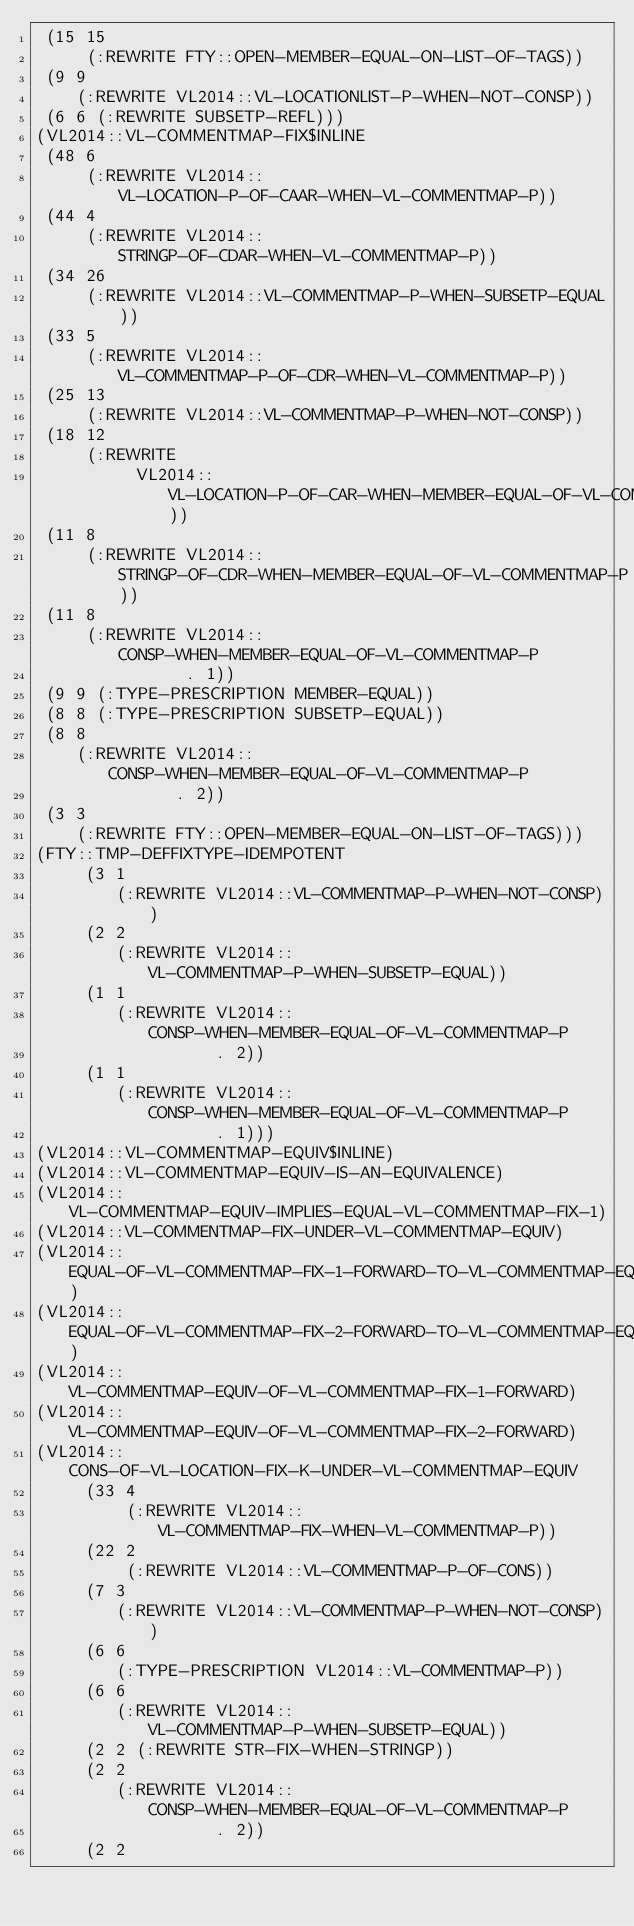<code> <loc_0><loc_0><loc_500><loc_500><_Lisp_> (15 15
     (:REWRITE FTY::OPEN-MEMBER-EQUAL-ON-LIST-OF-TAGS))
 (9 9
    (:REWRITE VL2014::VL-LOCATIONLIST-P-WHEN-NOT-CONSP))
 (6 6 (:REWRITE SUBSETP-REFL)))
(VL2014::VL-COMMENTMAP-FIX$INLINE
 (48 6
     (:REWRITE VL2014::VL-LOCATION-P-OF-CAAR-WHEN-VL-COMMENTMAP-P))
 (44 4
     (:REWRITE VL2014::STRINGP-OF-CDAR-WHEN-VL-COMMENTMAP-P))
 (34 26
     (:REWRITE VL2014::VL-COMMENTMAP-P-WHEN-SUBSETP-EQUAL))
 (33 5
     (:REWRITE VL2014::VL-COMMENTMAP-P-OF-CDR-WHEN-VL-COMMENTMAP-P))
 (25 13
     (:REWRITE VL2014::VL-COMMENTMAP-P-WHEN-NOT-CONSP))
 (18 12
     (:REWRITE
          VL2014::VL-LOCATION-P-OF-CAR-WHEN-MEMBER-EQUAL-OF-VL-COMMENTMAP-P))
 (11 8
     (:REWRITE VL2014::STRINGP-OF-CDR-WHEN-MEMBER-EQUAL-OF-VL-COMMENTMAP-P))
 (11 8
     (:REWRITE VL2014::CONSP-WHEN-MEMBER-EQUAL-OF-VL-COMMENTMAP-P
               . 1))
 (9 9 (:TYPE-PRESCRIPTION MEMBER-EQUAL))
 (8 8 (:TYPE-PRESCRIPTION SUBSETP-EQUAL))
 (8 8
    (:REWRITE VL2014::CONSP-WHEN-MEMBER-EQUAL-OF-VL-COMMENTMAP-P
              . 2))
 (3 3
    (:REWRITE FTY::OPEN-MEMBER-EQUAL-ON-LIST-OF-TAGS)))
(FTY::TMP-DEFFIXTYPE-IDEMPOTENT
     (3 1
        (:REWRITE VL2014::VL-COMMENTMAP-P-WHEN-NOT-CONSP))
     (2 2
        (:REWRITE VL2014::VL-COMMENTMAP-P-WHEN-SUBSETP-EQUAL))
     (1 1
        (:REWRITE VL2014::CONSP-WHEN-MEMBER-EQUAL-OF-VL-COMMENTMAP-P
                  . 2))
     (1 1
        (:REWRITE VL2014::CONSP-WHEN-MEMBER-EQUAL-OF-VL-COMMENTMAP-P
                  . 1)))
(VL2014::VL-COMMENTMAP-EQUIV$INLINE)
(VL2014::VL-COMMENTMAP-EQUIV-IS-AN-EQUIVALENCE)
(VL2014::VL-COMMENTMAP-EQUIV-IMPLIES-EQUAL-VL-COMMENTMAP-FIX-1)
(VL2014::VL-COMMENTMAP-FIX-UNDER-VL-COMMENTMAP-EQUIV)
(VL2014::EQUAL-OF-VL-COMMENTMAP-FIX-1-FORWARD-TO-VL-COMMENTMAP-EQUIV)
(VL2014::EQUAL-OF-VL-COMMENTMAP-FIX-2-FORWARD-TO-VL-COMMENTMAP-EQUIV)
(VL2014::VL-COMMENTMAP-EQUIV-OF-VL-COMMENTMAP-FIX-1-FORWARD)
(VL2014::VL-COMMENTMAP-EQUIV-OF-VL-COMMENTMAP-FIX-2-FORWARD)
(VL2014::CONS-OF-VL-LOCATION-FIX-K-UNDER-VL-COMMENTMAP-EQUIV
     (33 4
         (:REWRITE VL2014::VL-COMMENTMAP-FIX-WHEN-VL-COMMENTMAP-P))
     (22 2
         (:REWRITE VL2014::VL-COMMENTMAP-P-OF-CONS))
     (7 3
        (:REWRITE VL2014::VL-COMMENTMAP-P-WHEN-NOT-CONSP))
     (6 6
        (:TYPE-PRESCRIPTION VL2014::VL-COMMENTMAP-P))
     (6 6
        (:REWRITE VL2014::VL-COMMENTMAP-P-WHEN-SUBSETP-EQUAL))
     (2 2 (:REWRITE STR-FIX-WHEN-STRINGP))
     (2 2
        (:REWRITE VL2014::CONSP-WHEN-MEMBER-EQUAL-OF-VL-COMMENTMAP-P
                  . 2))
     (2 2</code> 